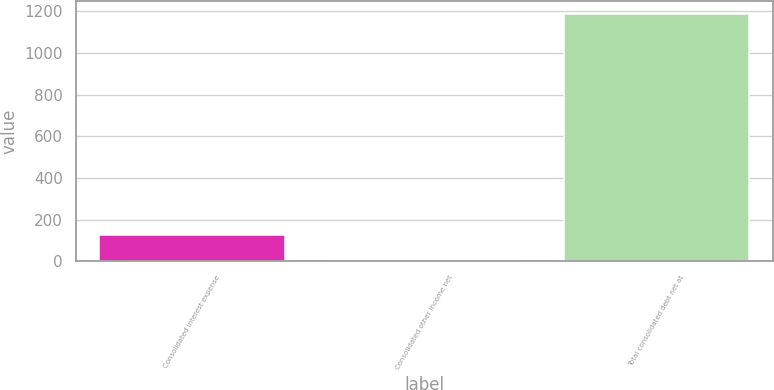Convert chart to OTSL. <chart><loc_0><loc_0><loc_500><loc_500><bar_chart><fcel>Consolidated interest expense<fcel>Consolidated other income net<fcel>Total consolidated debt net at<nl><fcel>124.62<fcel>6.5<fcel>1187.7<nl></chart> 